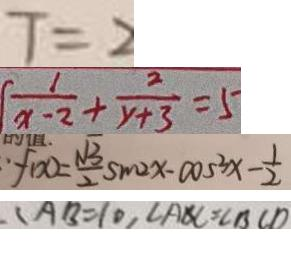Convert formula to latex. <formula><loc_0><loc_0><loc_500><loc_500>T = 2 
 \frac { 1 } { x - 2 } + \frac { 2 } { y + 3 } = 5 
 : f ( x ) = \frac { \sqrt { 3 } } { 2 } \sin 2 x - \cos ^ { 3 } x - \frac { 1 } { 2 } 
 \angle A B = 1 0 , \angle A B C = \angle B C D</formula> 